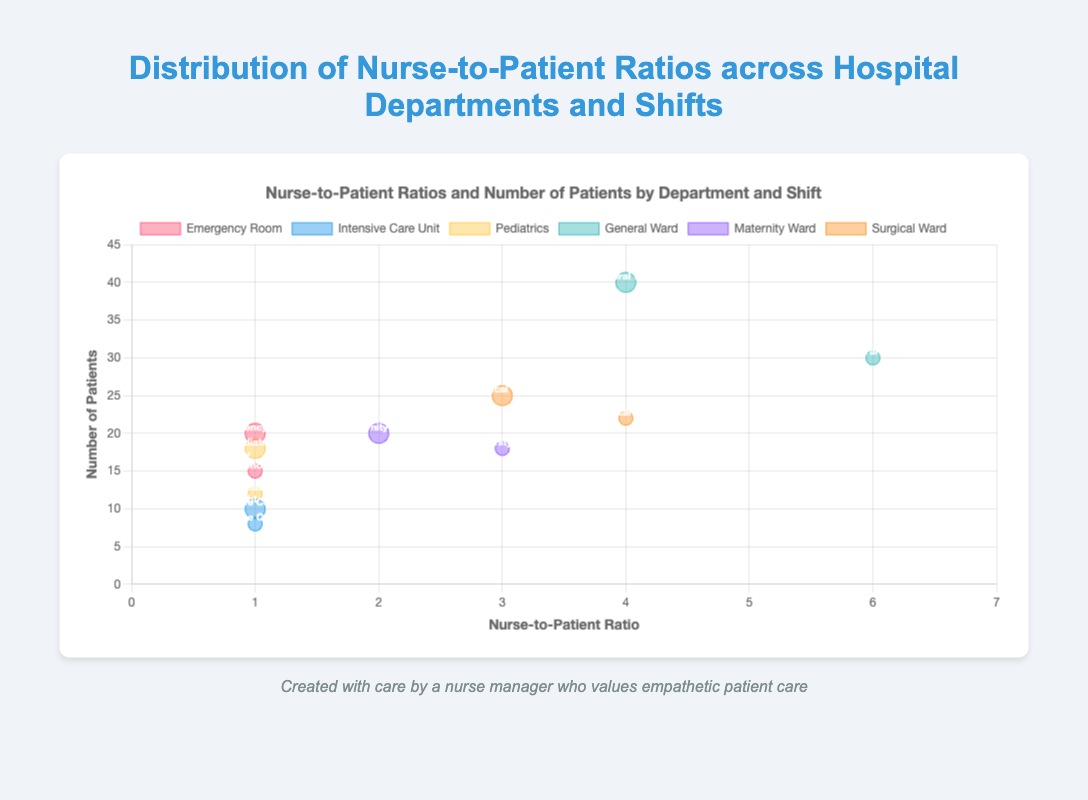What is the nurse-to-patient ratio in the General Ward during the night shift? The bubble chart shows the General Ward has a nurse-to-patient ratio of 6 during the night shift, which is represented by a corresponding data point on the x-axis.
Answer: 6 How many patients are there in the Intensive Care Unit during the day shift? Observing the bubble position for the Intensive Care Unit during the day shift on the y-axis, the number of patients is 10.
Answer: 10 Which department has the highest number of patients during the night shift? By looking at the y-axis values for all night shift bubbles, the General Ward has the highest number with 30 patients.
Answer: General Ward What is the title of the bubble chart? The title is displayed at the top of the chart.
Answer: Distribution of Nurse-to-Patient Ratios across Hospital Departments and Shifts Compare the nurse-to-patient ratios between the day and night shifts in the Maternity Ward. Which has a higher ratio? The bubble representing the day shift has a nurse-to-patient ratio of 2, while the night shift has 3. The night shift ratio is higher.
Answer: Night shift What is the total number of patients in the Pediatrics department across both shifts? Add the number of patients during the day shift (18) and the night shift (12): 18 + 12 = 30.
Answer: 30 Which department has the same nurse-to-patient ratio for both shifts, and what is that ratio? Observing the bubbles, both the Emergency Room and Intensive Care Unit have a 1:1 nurse-to-patient ratio for both day and night shifts.
Answer: Emergency Room, Intensive Care Unit; Ratio: 1 What is the nurse-to-patient ratio in the Emergency Room during the day shift? The bubble for the Emergency Room during the day shift shows a ratio of 1.
Answer: 1 How does the number of patients in the Surgical Ward during the day shift compare to the night shift? The bubble positions on the y-axis show 25 patients during the day shift and 22 patients during the night shift, indicating more patients during the day shift.
Answer: More during the day (25 vs. 22) In which department and shift is the nurse-to-patient ratio the lowest, and what is the number of patients? The lowest ratio of 1 is seen in the Emergency Room, Intensive Care Unit, and Pediatrics during both day and night shifts, each with respective patient counts from the chart.
Answer: Emergency Room, Intensive Care Unit, Pediatrics; 20, 15, 10, 8, 18, 12 